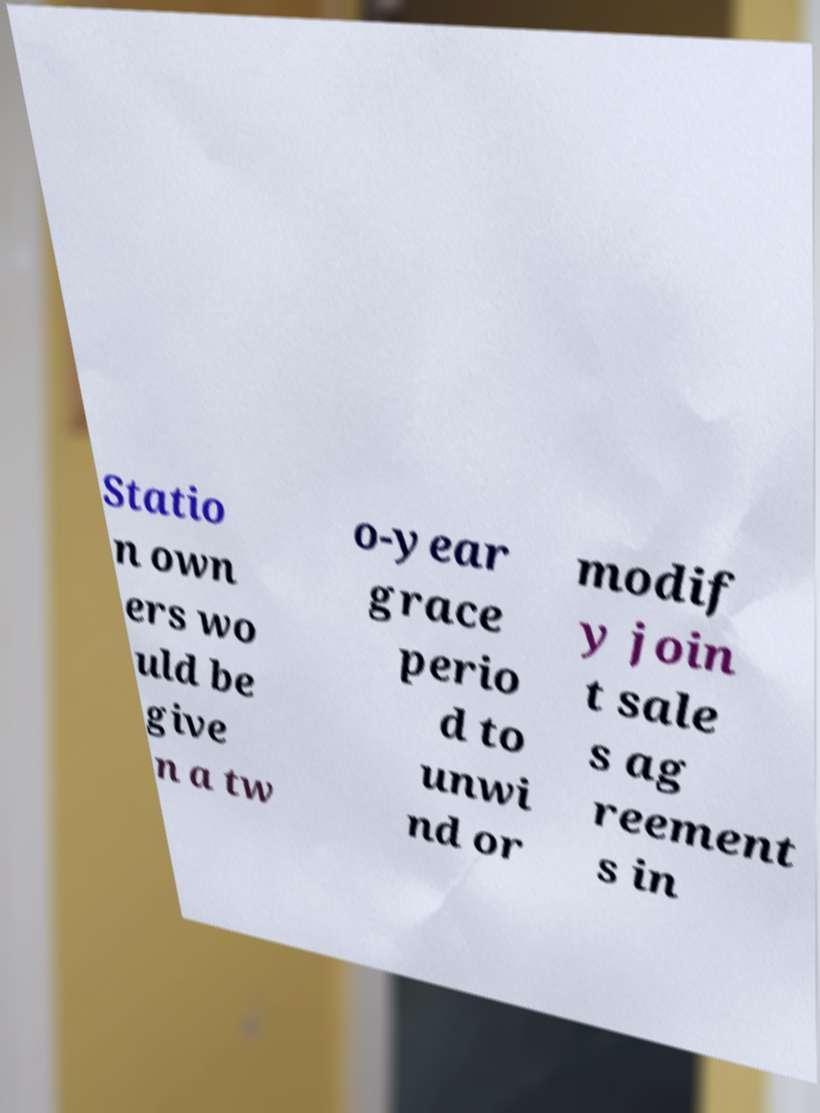There's text embedded in this image that I need extracted. Can you transcribe it verbatim? Statio n own ers wo uld be give n a tw o-year grace perio d to unwi nd or modif y join t sale s ag reement s in 